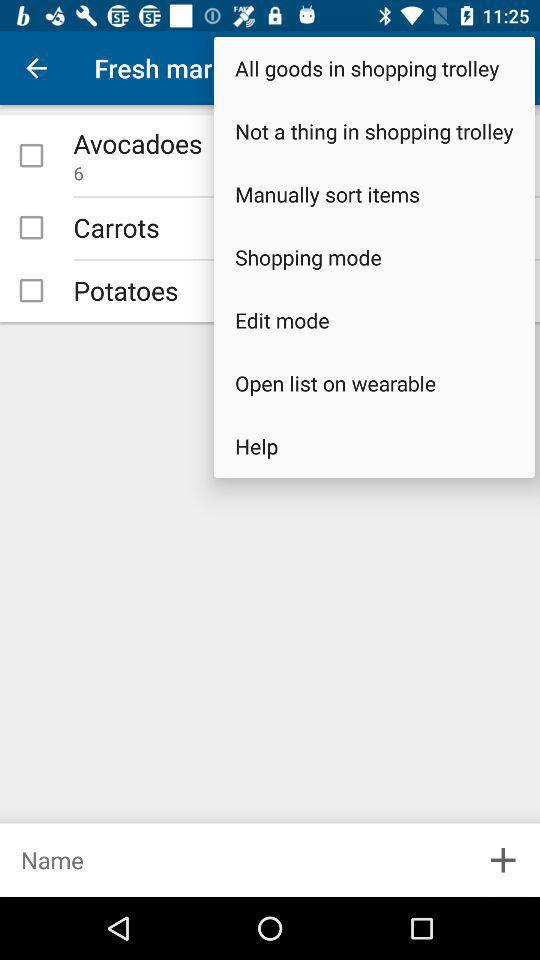How many items are in the shopping cart?
Answer the question using a single word or phrase. 3 